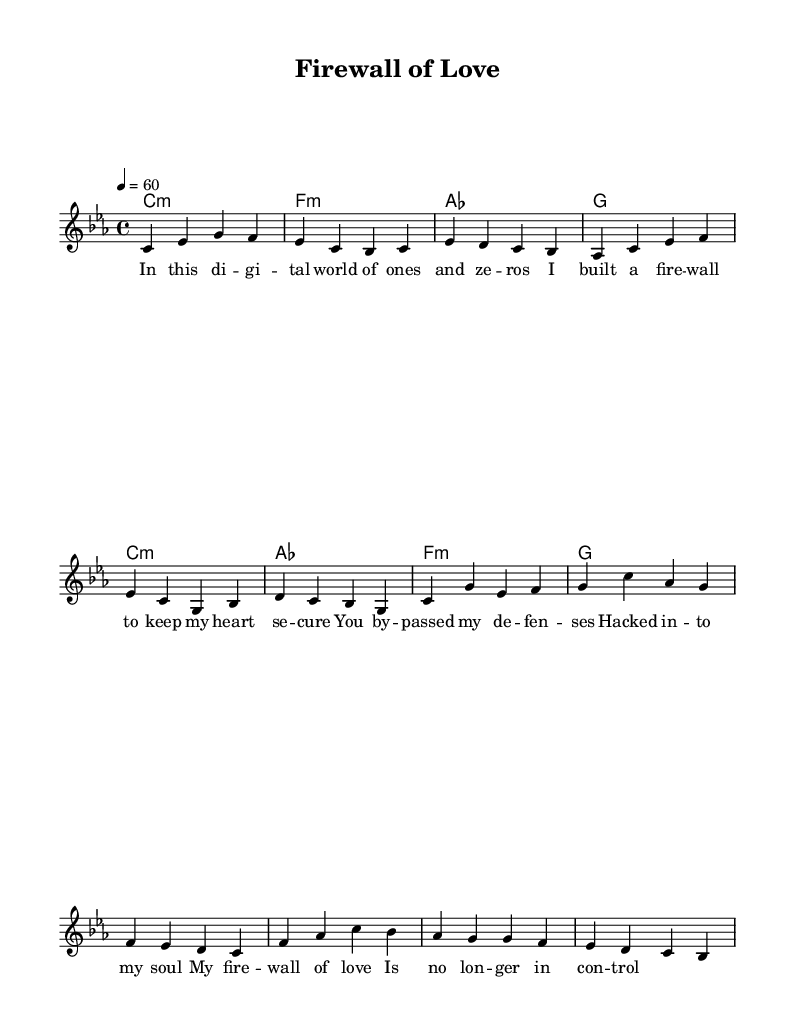What is the key signature of this music? The key signature is C minor, which has three flats (B-flat, E-flat, and A-flat). This is indicated at the beginning of the staff with the corresponding flats.
Answer: C minor What is the time signature of this piece? The time signature is indicated at the beginning of the sheet music and is represented as 4/4, which means there are four beats in each measure and the quarter note gets one beat.
Answer: 4/4 What is the tempo marking for this piece? The tempo marking indicates a speed of 60 beats per minute, which is shown at the beginning of the score as "4 = 60." This denotes how fast the piece should be played.
Answer: 60 How many measures are in the verse section? To count the measures in the verse section, one can look at the melody and count the segments separated by vertical lines. The verse comprises six measures before the chorus starts.
Answer: 6 What is the chord for the second measure of the verse? The chord for the second measure is indicated in the chord section and shows "f:m", indicating it is an F minor chord. This can be found directly beneath the corresponding melody notes in measure two.
Answer: F minor What theme is consistently present in the lyrics? The lyrics center around themes of cybersecurity, expressing feelings of vulnerability and the struggle to maintain control over personal security, as indicated by phrases like "firewall" and "hacked into my soul."
Answer: Cybersecurity How does the structure of the song reflect traditional rhythm and blues? The song has a verse-chorus structure commonly found in rhythm and blues, with the lyrical and harmonic content that captures emotional expressions typical of this genre, reinforcing the connection between love and protection in the context of cybersecurity.
Answer: Verse-chorus structure 